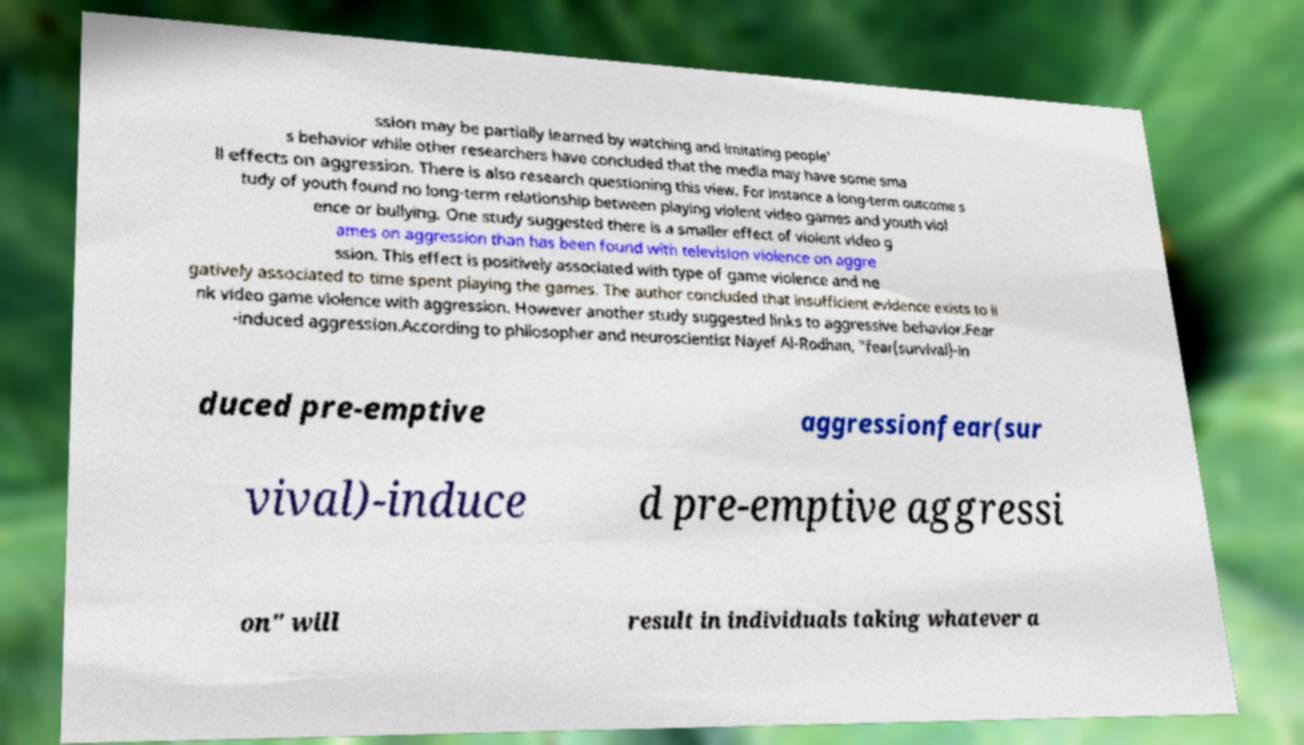There's text embedded in this image that I need extracted. Can you transcribe it verbatim? ssion may be partially learned by watching and imitating people' s behavior while other researchers have concluded that the media may have some sma ll effects on aggression. There is also research questioning this view. For instance a long-term outcome s tudy of youth found no long-term relationship between playing violent video games and youth viol ence or bullying. One study suggested there is a smaller effect of violent video g ames on aggression than has been found with television violence on aggre ssion. This effect is positively associated with type of game violence and ne gatively associated to time spent playing the games. The author concluded that insufficient evidence exists to li nk video game violence with aggression. However another study suggested links to aggressive behavior.Fear -induced aggression.According to philosopher and neuroscientist Nayef Al-Rodhan, "fear(survival)-in duced pre-emptive aggressionfear(sur vival)-induce d pre-emptive aggressi on" will result in individuals taking whatever a 